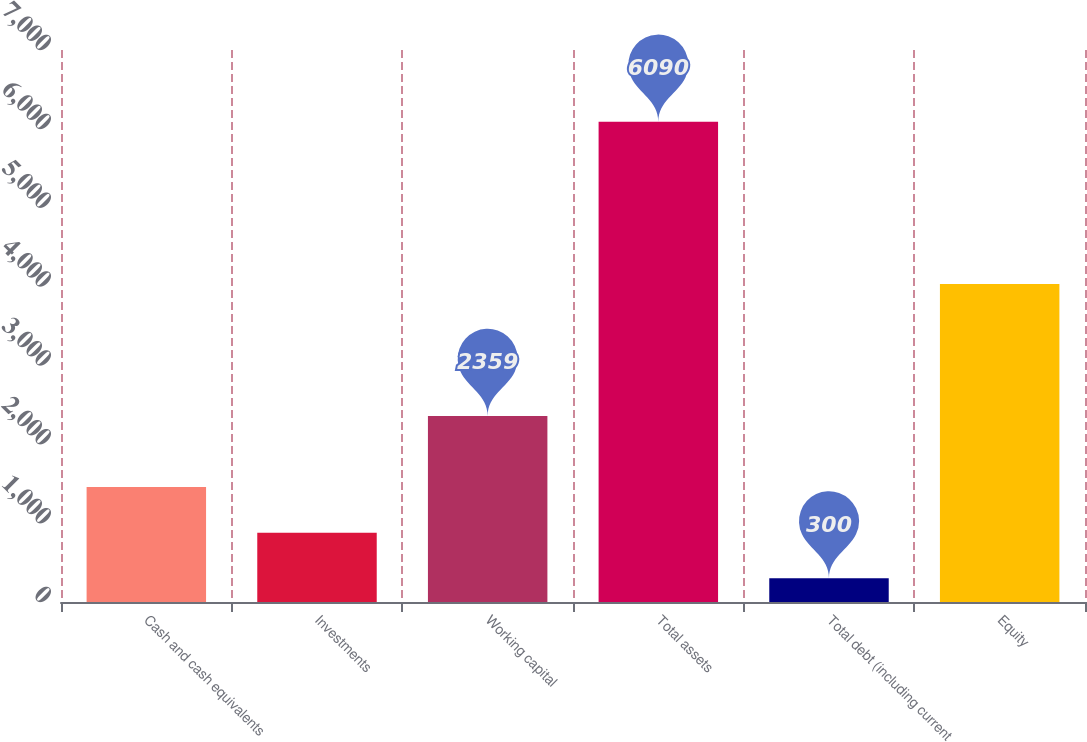<chart> <loc_0><loc_0><loc_500><loc_500><bar_chart><fcel>Cash and cash equivalents<fcel>Investments<fcel>Working capital<fcel>Total assets<fcel>Total debt (including current<fcel>Equity<nl><fcel>1458<fcel>879<fcel>2359<fcel>6090<fcel>300<fcel>4034<nl></chart> 